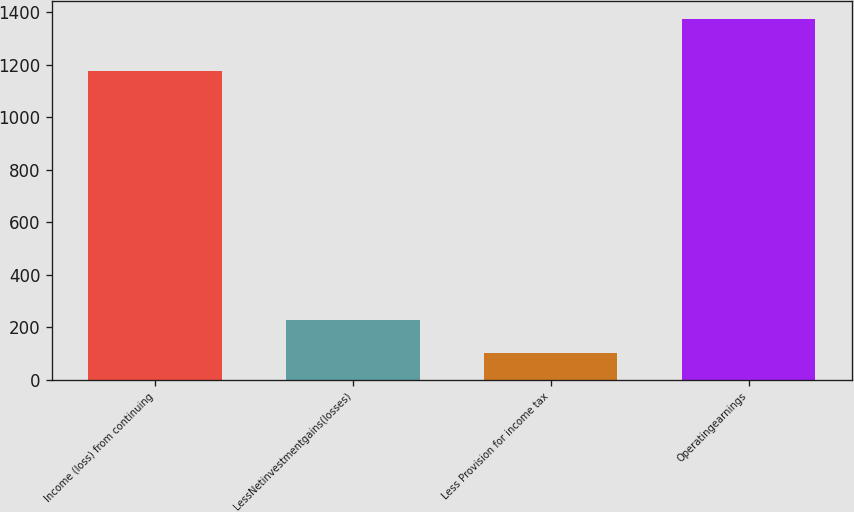Convert chart. <chart><loc_0><loc_0><loc_500><loc_500><bar_chart><fcel>Income (loss) from continuing<fcel>LessNetinvestmentgains(losses)<fcel>Less Provision for income tax<fcel>Operatingearnings<nl><fcel>1177<fcel>227.4<fcel>100<fcel>1374<nl></chart> 